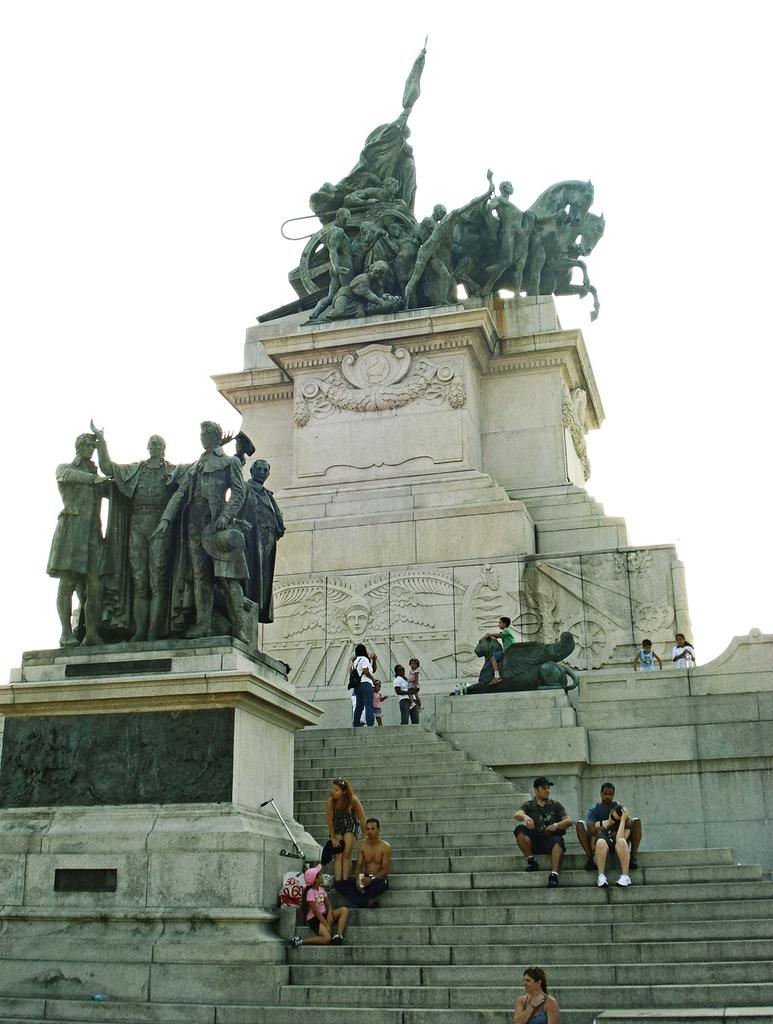How many people are in the image? There is a group of people in the image. What are the people in the image doing? Some people are standing, while others are sitting on the stairs. What other subjects are present in the image besides people? There are sculptures of people and horses in the image. What can be seen in the background of the image? The sky is visible in the background of the image. What type of lawyer is depicted in the image? There is no lawyer present in the image. Can you see anyone swinging in the image? There is no swing present in the image. 